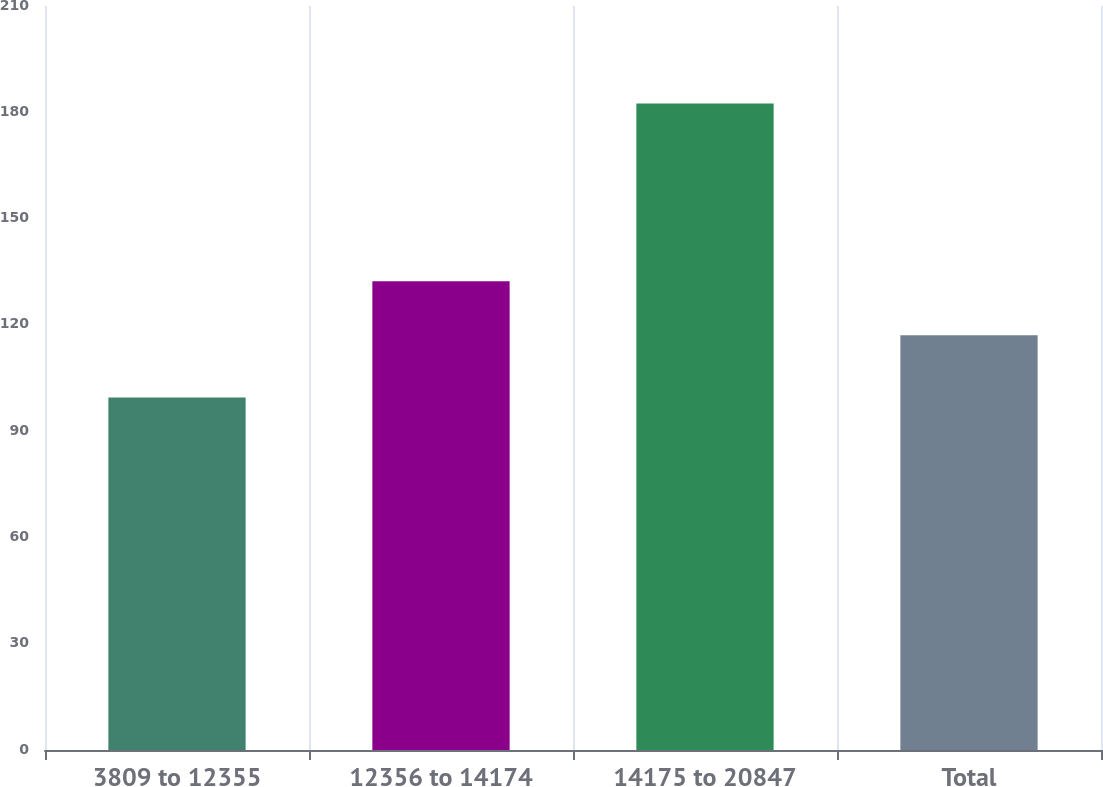Convert chart. <chart><loc_0><loc_0><loc_500><loc_500><bar_chart><fcel>3809 to 12355<fcel>12356 to 14174<fcel>14175 to 20847<fcel>Total<nl><fcel>99.53<fcel>132.29<fcel>182.46<fcel>117.08<nl></chart> 